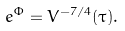<formula> <loc_0><loc_0><loc_500><loc_500>e ^ { \Phi } = V ^ { - 7 / 4 } ( \tau ) .</formula> 